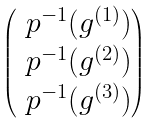<formula> <loc_0><loc_0><loc_500><loc_500>\begin{pmatrix} \ p ^ { - 1 } ( g ^ { ( 1 ) } ) \\ \ p ^ { - 1 } ( g ^ { ( 2 ) } ) \\ \ p ^ { - 1 } ( g ^ { ( 3 ) } ) \end{pmatrix}</formula> 